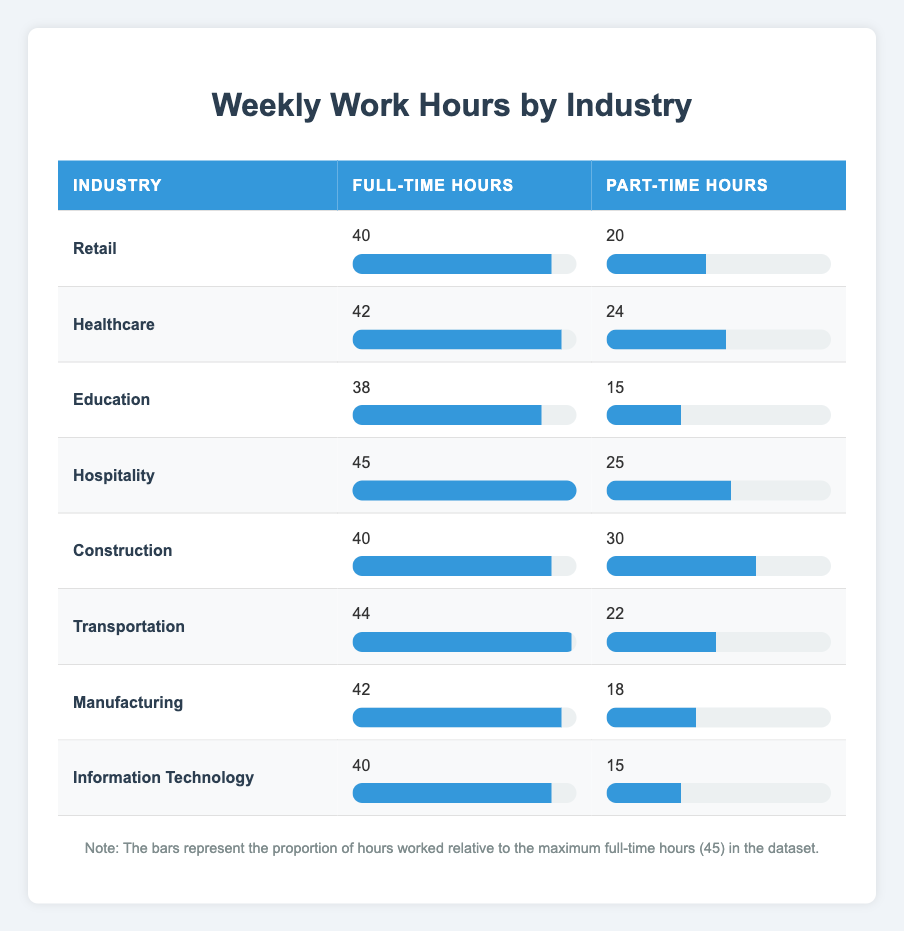What is the maximum number of hours worked in a full-time job across all industries? The full-time hours for each industry are 40, 42, 38, 45, 40, 44, 42, and 40. The maximum value is 45, which is from the Hospitality industry.
Answer: 45 Which industry has the least difference between full-time and part-time hours? To find the difference, we subtract part-time hours from full-time hours for each industry: Retail (20), Healthcare (18), Education (23), Hospitality (20), Construction (10), Transportation (22), Manufacturing (24), IT (25). The least difference is 10 in Construction.
Answer: Construction Is the part-time work in Healthcare greater than the part-time work in Education? The part-time hours for Healthcare are 24, and for Education, they are 15. Since 24 is greater than 15, the statement is true.
Answer: Yes What is the total number of hours worked if you combine all full-time hours? Adding the full-time hours from each industry gives us: 40 + 42 + 38 + 45 + 40 + 44 + 42 + 40 = 331 total hours worked in full-time jobs across all industries.
Answer: 331 What is the average number of part-time hours worked across all industries? The part-time hours are 20, 24, 15, 25, 30, 22, 18, and 15. The sum is 20 + 24 + 15 + 25 + 30 + 22 + 18 + 15 = 169. There are 8 values, hence the average is 169 divided by 8, which equals 21.125.
Answer: 21.125 Which industries have at least 40 hours in part-time work? Checking the part-time hours, the industries with at least 40 hours are Construction (30) and Hospitality (25). None are 40 or more. Therefore, no industries meet this criterion.
Answer: No What is the total number of hours worked for all jobs in the Construction industry? Full-time hours in Construction are 40 and part-time hours are 30. Summing them gives 40 + 30 = 70 total hours worked in the Construction industry.
Answer: 70 Which industry has the highest total hours (full-time + part-time)? We calculate total hours for each: Retail (60), Healthcare (66), Education (53), Hospitality (70), Construction (70), Transportation (66), Manufacturing (60), IT (55). The highest total is 70 hours in Hospitality and Construction.
Answer: Hospitality and Construction 